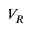<formula> <loc_0><loc_0><loc_500><loc_500>V _ { R }</formula> 